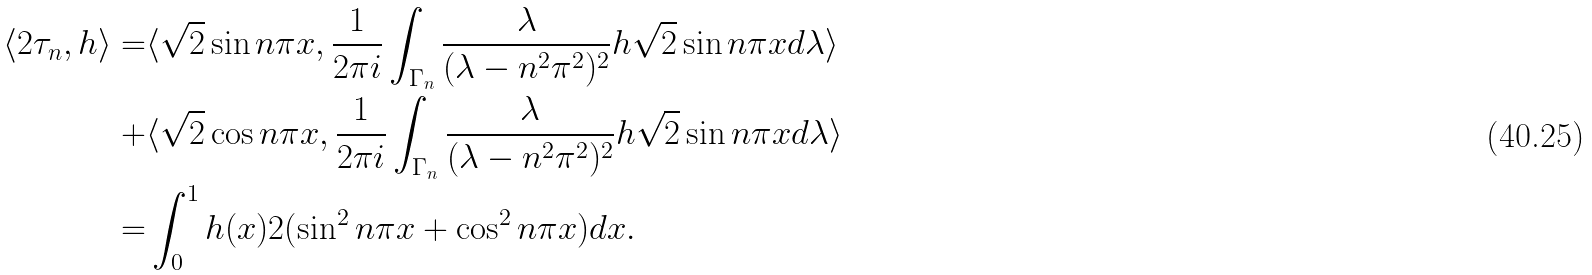Convert formula to latex. <formula><loc_0><loc_0><loc_500><loc_500>\langle 2 \tau _ { n } , h \rangle = & \langle \sqrt { 2 } \sin n \pi x , \frac { 1 } { 2 \pi i } \int _ { \Gamma _ { n } } \frac { \lambda } { ( \lambda - n ^ { 2 } \pi ^ { 2 } ) ^ { 2 } } h \sqrt { 2 } \sin n \pi x d \lambda \rangle \\ + & \langle \sqrt { 2 } \cos n \pi x , \frac { 1 } { 2 \pi i } \int _ { \Gamma _ { n } } \frac { \lambda } { ( \lambda - n ^ { 2 } \pi ^ { 2 } ) ^ { 2 } } h \sqrt { 2 } \sin n \pi x d \lambda \rangle \\ = & \int _ { 0 } ^ { 1 } h ( x ) 2 ( \sin ^ { 2 } n \pi x + \cos ^ { 2 } n \pi x ) d x .</formula> 